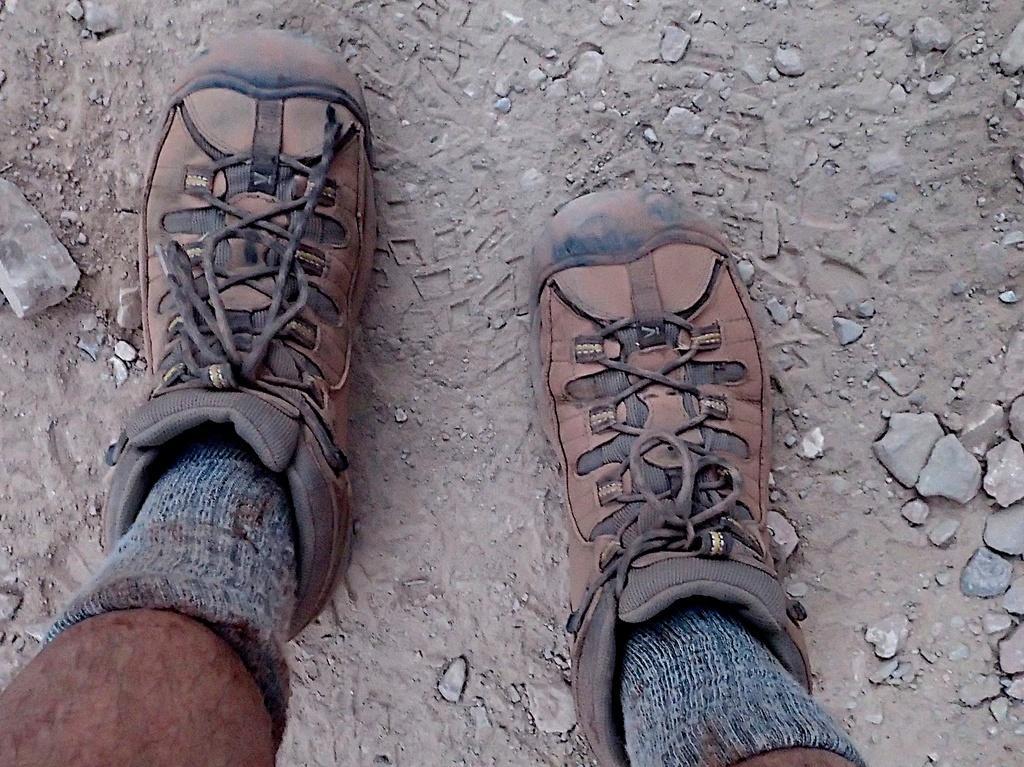Could you give a brief overview of what you see in this image? In the center of the image we can see a person legs, wearing shoes with laces and socks. In the background of the image we can see some stones and ground. 